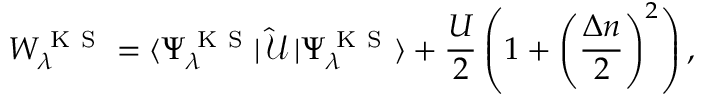Convert formula to latex. <formula><loc_0><loc_0><loc_500><loc_500>W _ { \lambda } ^ { K S } = \langle \Psi _ { \lambda } ^ { K S } | \, \mathcal { \hat { U } } \, | \Psi _ { \lambda } ^ { K S } \rangle + \frac { U } { 2 } \left ( 1 + \left ( \frac { \Delta n } { 2 } \right ) ^ { 2 } \right ) ,</formula> 